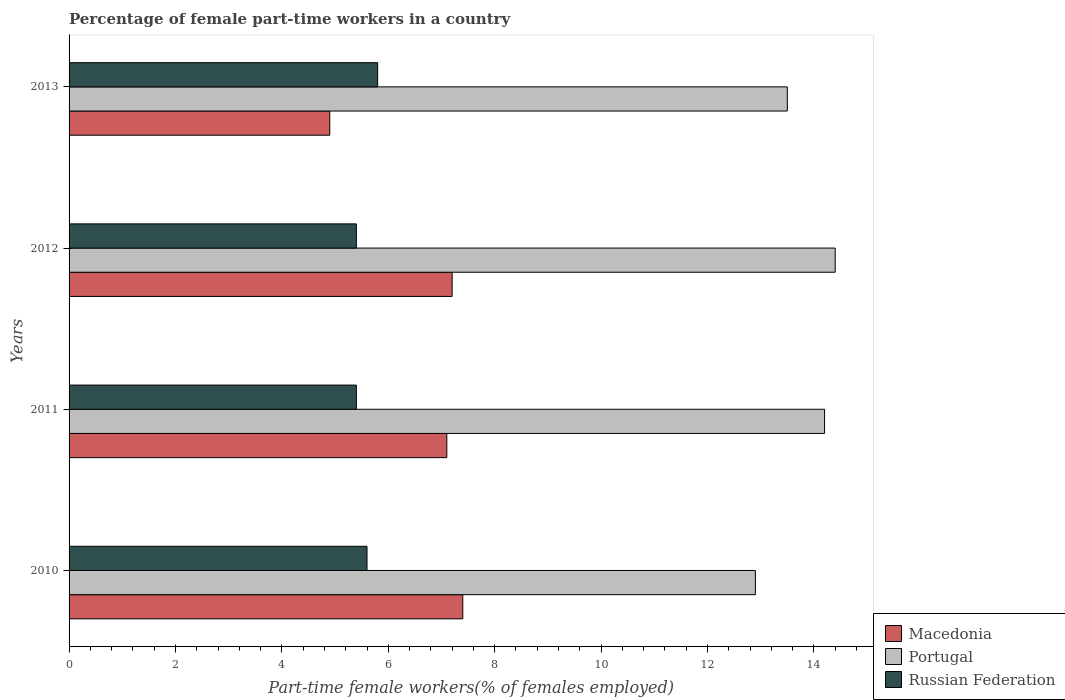How many different coloured bars are there?
Make the answer very short. 3. How many groups of bars are there?
Your response must be concise. 4. Are the number of bars per tick equal to the number of legend labels?
Your answer should be compact. Yes. How many bars are there on the 2nd tick from the bottom?
Your answer should be very brief. 3. In how many cases, is the number of bars for a given year not equal to the number of legend labels?
Make the answer very short. 0. What is the percentage of female part-time workers in Portugal in 2010?
Give a very brief answer. 12.9. Across all years, what is the maximum percentage of female part-time workers in Portugal?
Your answer should be very brief. 14.4. Across all years, what is the minimum percentage of female part-time workers in Russian Federation?
Offer a very short reply. 5.4. What is the total percentage of female part-time workers in Macedonia in the graph?
Your response must be concise. 26.6. What is the difference between the percentage of female part-time workers in Portugal in 2010 and that in 2013?
Offer a terse response. -0.6. What is the difference between the percentage of female part-time workers in Portugal in 2010 and the percentage of female part-time workers in Macedonia in 2011?
Offer a very short reply. 5.8. What is the average percentage of female part-time workers in Portugal per year?
Give a very brief answer. 13.75. In the year 2010, what is the difference between the percentage of female part-time workers in Portugal and percentage of female part-time workers in Russian Federation?
Ensure brevity in your answer.  7.3. In how many years, is the percentage of female part-time workers in Macedonia greater than 3.2 %?
Provide a short and direct response. 4. What is the ratio of the percentage of female part-time workers in Macedonia in 2011 to that in 2013?
Provide a succinct answer. 1.45. Is the percentage of female part-time workers in Macedonia in 2010 less than that in 2013?
Provide a short and direct response. No. Is the difference between the percentage of female part-time workers in Portugal in 2011 and 2013 greater than the difference between the percentage of female part-time workers in Russian Federation in 2011 and 2013?
Provide a short and direct response. Yes. What is the difference between the highest and the second highest percentage of female part-time workers in Portugal?
Offer a terse response. 0.2. What does the 1st bar from the top in 2012 represents?
Your answer should be very brief. Russian Federation. Is it the case that in every year, the sum of the percentage of female part-time workers in Macedonia and percentage of female part-time workers in Russian Federation is greater than the percentage of female part-time workers in Portugal?
Your response must be concise. No. Are all the bars in the graph horizontal?
Give a very brief answer. Yes. How many years are there in the graph?
Provide a short and direct response. 4. What is the difference between two consecutive major ticks on the X-axis?
Provide a succinct answer. 2. Are the values on the major ticks of X-axis written in scientific E-notation?
Your answer should be very brief. No. What is the title of the graph?
Provide a succinct answer. Percentage of female part-time workers in a country. Does "Guatemala" appear as one of the legend labels in the graph?
Your answer should be very brief. No. What is the label or title of the X-axis?
Your answer should be very brief. Part-time female workers(% of females employed). What is the label or title of the Y-axis?
Make the answer very short. Years. What is the Part-time female workers(% of females employed) in Macedonia in 2010?
Your response must be concise. 7.4. What is the Part-time female workers(% of females employed) of Portugal in 2010?
Give a very brief answer. 12.9. What is the Part-time female workers(% of females employed) of Russian Federation in 2010?
Keep it short and to the point. 5.6. What is the Part-time female workers(% of females employed) in Macedonia in 2011?
Ensure brevity in your answer.  7.1. What is the Part-time female workers(% of females employed) of Portugal in 2011?
Your response must be concise. 14.2. What is the Part-time female workers(% of females employed) of Russian Federation in 2011?
Your answer should be compact. 5.4. What is the Part-time female workers(% of females employed) of Macedonia in 2012?
Give a very brief answer. 7.2. What is the Part-time female workers(% of females employed) in Portugal in 2012?
Offer a very short reply. 14.4. What is the Part-time female workers(% of females employed) in Russian Federation in 2012?
Offer a very short reply. 5.4. What is the Part-time female workers(% of females employed) of Macedonia in 2013?
Your answer should be very brief. 4.9. What is the Part-time female workers(% of females employed) in Portugal in 2013?
Your answer should be compact. 13.5. What is the Part-time female workers(% of females employed) in Russian Federation in 2013?
Your answer should be compact. 5.8. Across all years, what is the maximum Part-time female workers(% of females employed) in Macedonia?
Give a very brief answer. 7.4. Across all years, what is the maximum Part-time female workers(% of females employed) in Portugal?
Your answer should be compact. 14.4. Across all years, what is the maximum Part-time female workers(% of females employed) of Russian Federation?
Offer a very short reply. 5.8. Across all years, what is the minimum Part-time female workers(% of females employed) in Macedonia?
Your answer should be very brief. 4.9. Across all years, what is the minimum Part-time female workers(% of females employed) in Portugal?
Keep it short and to the point. 12.9. Across all years, what is the minimum Part-time female workers(% of females employed) in Russian Federation?
Keep it short and to the point. 5.4. What is the total Part-time female workers(% of females employed) in Macedonia in the graph?
Offer a terse response. 26.6. What is the total Part-time female workers(% of females employed) of Portugal in the graph?
Your answer should be very brief. 55. What is the difference between the Part-time female workers(% of females employed) of Portugal in 2010 and that in 2011?
Your answer should be compact. -1.3. What is the difference between the Part-time female workers(% of females employed) of Macedonia in 2010 and that in 2012?
Keep it short and to the point. 0.2. What is the difference between the Part-time female workers(% of females employed) in Portugal in 2010 and that in 2012?
Give a very brief answer. -1.5. What is the difference between the Part-time female workers(% of females employed) of Russian Federation in 2010 and that in 2012?
Keep it short and to the point. 0.2. What is the difference between the Part-time female workers(% of females employed) of Portugal in 2010 and that in 2013?
Offer a very short reply. -0.6. What is the difference between the Part-time female workers(% of females employed) of Portugal in 2011 and that in 2012?
Offer a very short reply. -0.2. What is the difference between the Part-time female workers(% of females employed) of Russian Federation in 2011 and that in 2012?
Keep it short and to the point. 0. What is the difference between the Part-time female workers(% of females employed) of Russian Federation in 2011 and that in 2013?
Make the answer very short. -0.4. What is the difference between the Part-time female workers(% of females employed) in Portugal in 2012 and that in 2013?
Provide a short and direct response. 0.9. What is the difference between the Part-time female workers(% of females employed) in Russian Federation in 2012 and that in 2013?
Provide a succinct answer. -0.4. What is the difference between the Part-time female workers(% of females employed) in Macedonia in 2010 and the Part-time female workers(% of females employed) in Portugal in 2011?
Provide a short and direct response. -6.8. What is the difference between the Part-time female workers(% of females employed) of Portugal in 2010 and the Part-time female workers(% of females employed) of Russian Federation in 2011?
Provide a succinct answer. 7.5. What is the difference between the Part-time female workers(% of females employed) in Macedonia in 2010 and the Part-time female workers(% of females employed) in Portugal in 2012?
Your answer should be compact. -7. What is the difference between the Part-time female workers(% of females employed) of Macedonia in 2010 and the Part-time female workers(% of females employed) of Russian Federation in 2012?
Ensure brevity in your answer.  2. What is the difference between the Part-time female workers(% of females employed) in Portugal in 2010 and the Part-time female workers(% of females employed) in Russian Federation in 2012?
Ensure brevity in your answer.  7.5. What is the difference between the Part-time female workers(% of females employed) in Macedonia in 2010 and the Part-time female workers(% of females employed) in Russian Federation in 2013?
Provide a short and direct response. 1.6. What is the difference between the Part-time female workers(% of females employed) of Portugal in 2010 and the Part-time female workers(% of females employed) of Russian Federation in 2013?
Make the answer very short. 7.1. What is the difference between the Part-time female workers(% of females employed) in Macedonia in 2011 and the Part-time female workers(% of females employed) in Russian Federation in 2012?
Offer a very short reply. 1.7. What is the difference between the Part-time female workers(% of females employed) of Portugal in 2011 and the Part-time female workers(% of females employed) of Russian Federation in 2012?
Make the answer very short. 8.8. What is the difference between the Part-time female workers(% of females employed) in Macedonia in 2011 and the Part-time female workers(% of females employed) in Portugal in 2013?
Provide a succinct answer. -6.4. What is the average Part-time female workers(% of females employed) of Macedonia per year?
Provide a short and direct response. 6.65. What is the average Part-time female workers(% of females employed) in Portugal per year?
Offer a terse response. 13.75. What is the average Part-time female workers(% of females employed) in Russian Federation per year?
Offer a terse response. 5.55. In the year 2012, what is the difference between the Part-time female workers(% of females employed) of Macedonia and Part-time female workers(% of females employed) of Russian Federation?
Make the answer very short. 1.8. In the year 2013, what is the difference between the Part-time female workers(% of females employed) of Macedonia and Part-time female workers(% of females employed) of Portugal?
Your response must be concise. -8.6. In the year 2013, what is the difference between the Part-time female workers(% of females employed) of Macedonia and Part-time female workers(% of females employed) of Russian Federation?
Give a very brief answer. -0.9. What is the ratio of the Part-time female workers(% of females employed) in Macedonia in 2010 to that in 2011?
Your response must be concise. 1.04. What is the ratio of the Part-time female workers(% of females employed) in Portugal in 2010 to that in 2011?
Provide a short and direct response. 0.91. What is the ratio of the Part-time female workers(% of females employed) of Russian Federation in 2010 to that in 2011?
Your answer should be very brief. 1.04. What is the ratio of the Part-time female workers(% of females employed) of Macedonia in 2010 to that in 2012?
Provide a succinct answer. 1.03. What is the ratio of the Part-time female workers(% of females employed) of Portugal in 2010 to that in 2012?
Provide a short and direct response. 0.9. What is the ratio of the Part-time female workers(% of females employed) of Russian Federation in 2010 to that in 2012?
Your answer should be compact. 1.04. What is the ratio of the Part-time female workers(% of females employed) in Macedonia in 2010 to that in 2013?
Ensure brevity in your answer.  1.51. What is the ratio of the Part-time female workers(% of females employed) of Portugal in 2010 to that in 2013?
Ensure brevity in your answer.  0.96. What is the ratio of the Part-time female workers(% of females employed) of Russian Federation in 2010 to that in 2013?
Your response must be concise. 0.97. What is the ratio of the Part-time female workers(% of females employed) in Macedonia in 2011 to that in 2012?
Keep it short and to the point. 0.99. What is the ratio of the Part-time female workers(% of females employed) of Portugal in 2011 to that in 2012?
Ensure brevity in your answer.  0.99. What is the ratio of the Part-time female workers(% of females employed) in Macedonia in 2011 to that in 2013?
Provide a short and direct response. 1.45. What is the ratio of the Part-time female workers(% of females employed) in Portugal in 2011 to that in 2013?
Provide a short and direct response. 1.05. What is the ratio of the Part-time female workers(% of females employed) of Macedonia in 2012 to that in 2013?
Provide a short and direct response. 1.47. What is the ratio of the Part-time female workers(% of females employed) in Portugal in 2012 to that in 2013?
Your answer should be compact. 1.07. What is the ratio of the Part-time female workers(% of females employed) of Russian Federation in 2012 to that in 2013?
Provide a short and direct response. 0.93. What is the difference between the highest and the second highest Part-time female workers(% of females employed) in Macedonia?
Ensure brevity in your answer.  0.2. What is the difference between the highest and the lowest Part-time female workers(% of females employed) of Portugal?
Provide a succinct answer. 1.5. 